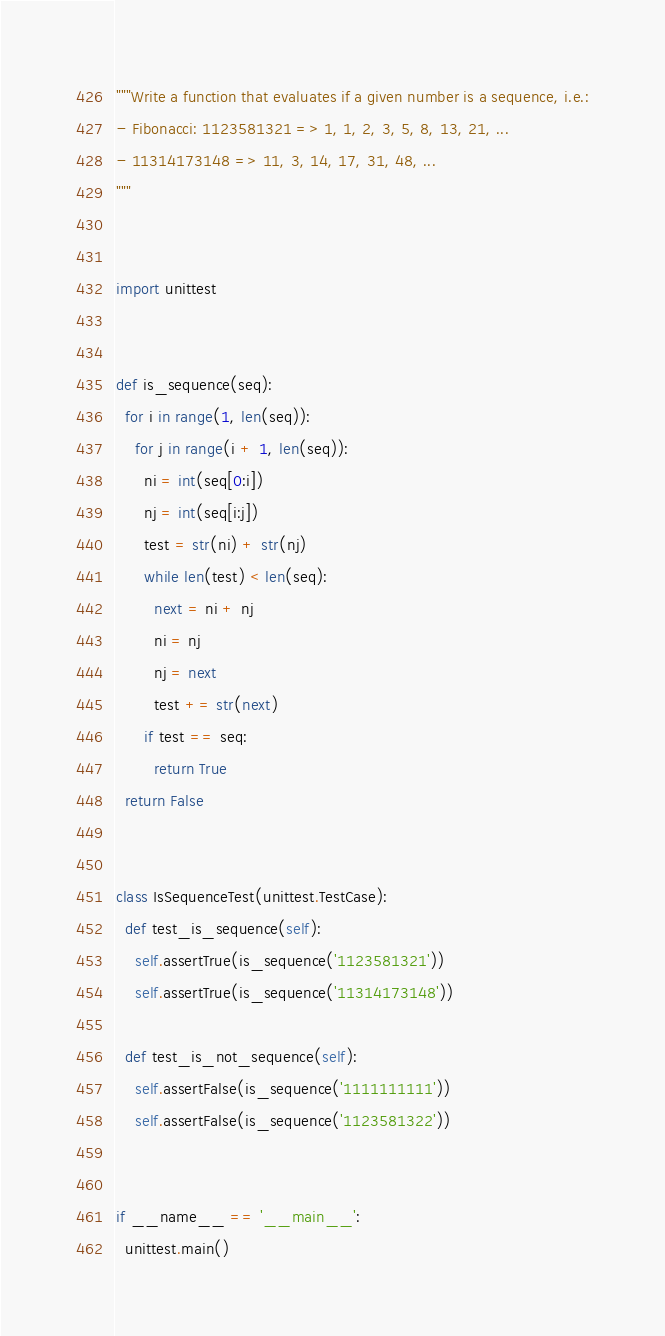Convert code to text. <code><loc_0><loc_0><loc_500><loc_500><_Python_>"""Write a function that evaluates if a given number is a sequence, i.e.:
- Fibonacci: 1123581321 => 1, 1, 2, 3, 5, 8, 13, 21, ...
- 11314173148 => 11, 3, 14, 17, 31, 48, ...
"""


import unittest


def is_sequence(seq):
  for i in range(1, len(seq)):
    for j in range(i + 1, len(seq)):
      ni = int(seq[0:i])
      nj = int(seq[i:j])
      test = str(ni) + str(nj)
      while len(test) < len(seq):
        next = ni + nj
        ni = nj
        nj = next
        test += str(next)
      if test == seq:
        return True
  return False


class IsSequenceTest(unittest.TestCase):
  def test_is_sequence(self):
    self.assertTrue(is_sequence('1123581321'))
    self.assertTrue(is_sequence('11314173148'))

  def test_is_not_sequence(self):
    self.assertFalse(is_sequence('1111111111'))
    self.assertFalse(is_sequence('1123581322'))


if __name__ == '__main__':
  unittest.main()
</code> 